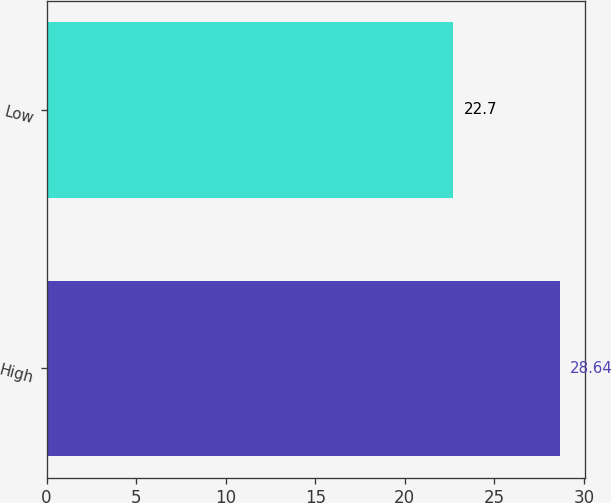Convert chart to OTSL. <chart><loc_0><loc_0><loc_500><loc_500><bar_chart><fcel>High<fcel>Low<nl><fcel>28.64<fcel>22.7<nl></chart> 